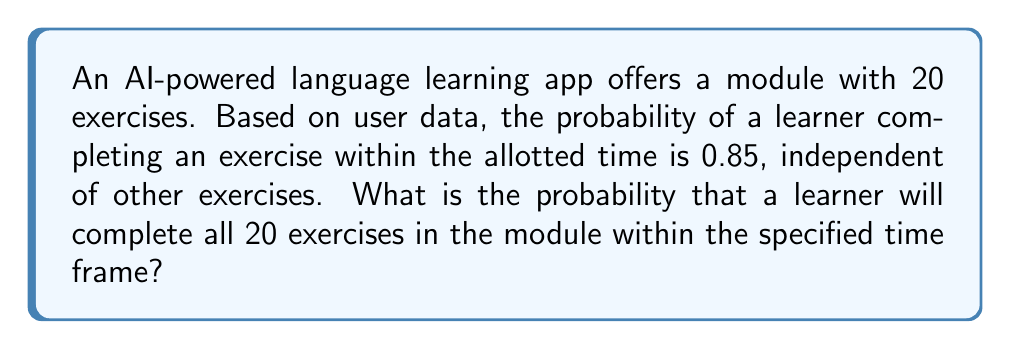What is the answer to this math problem? To solve this problem, we need to consider the following:

1. Each exercise completion is an independent event.
2. The probability of completing each exercise is 0.85.
3. We need all 20 exercises to be completed within the time frame.

This scenario follows a binomial probability distribution, but we're interested in the probability of all exercises being completed, which is equivalent to the probability of exactly 20 successes out of 20 trials.

The probability of all exercises being completed is the product of the individual probabilities:

$$ P(\text{all completed}) = 0.85 \times 0.85 \times ... \times 0.85 \text{ (20 times)} $$

This can be written as:

$$ P(\text{all completed}) = (0.85)^{20} $$

Using a calculator or computer to evaluate this expression:

$$ (0.85)^{20} \approx 0.0388 $$

Therefore, the probability of a learner completing all 20 exercises within the specified time frame is approximately 0.0388 or 3.88%.
Answer: The probability is approximately 0.0388 or 3.88%. 